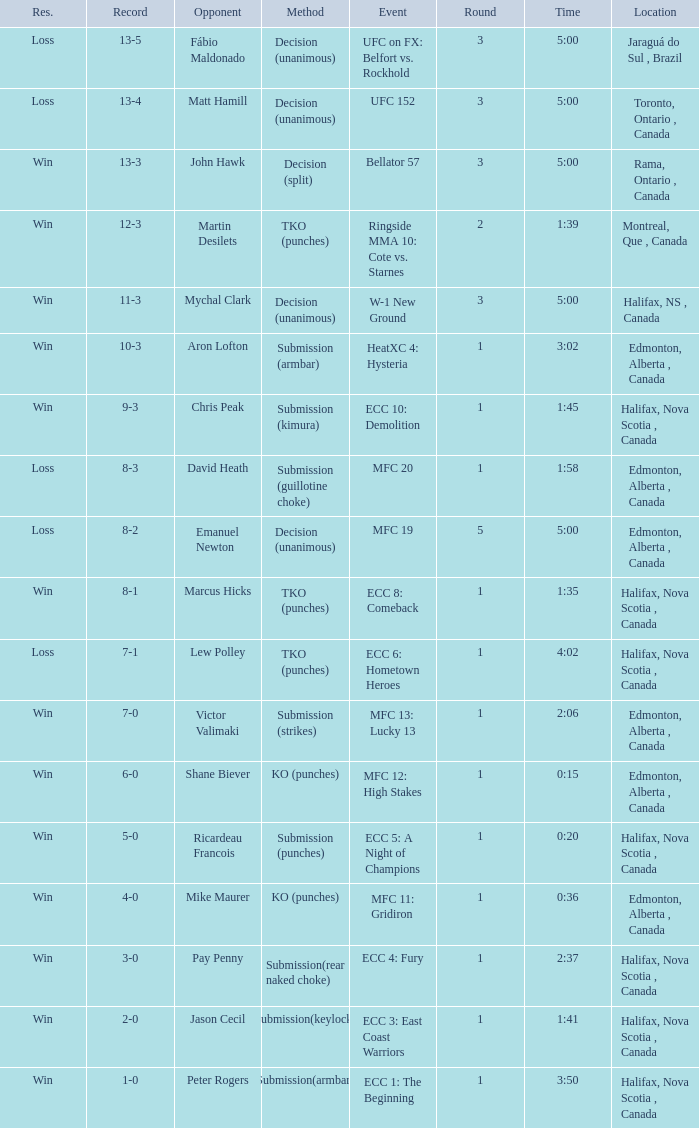What is the venue for the contest containing an ecc 8: comeback incident? Halifax, Nova Scotia , Canada. 